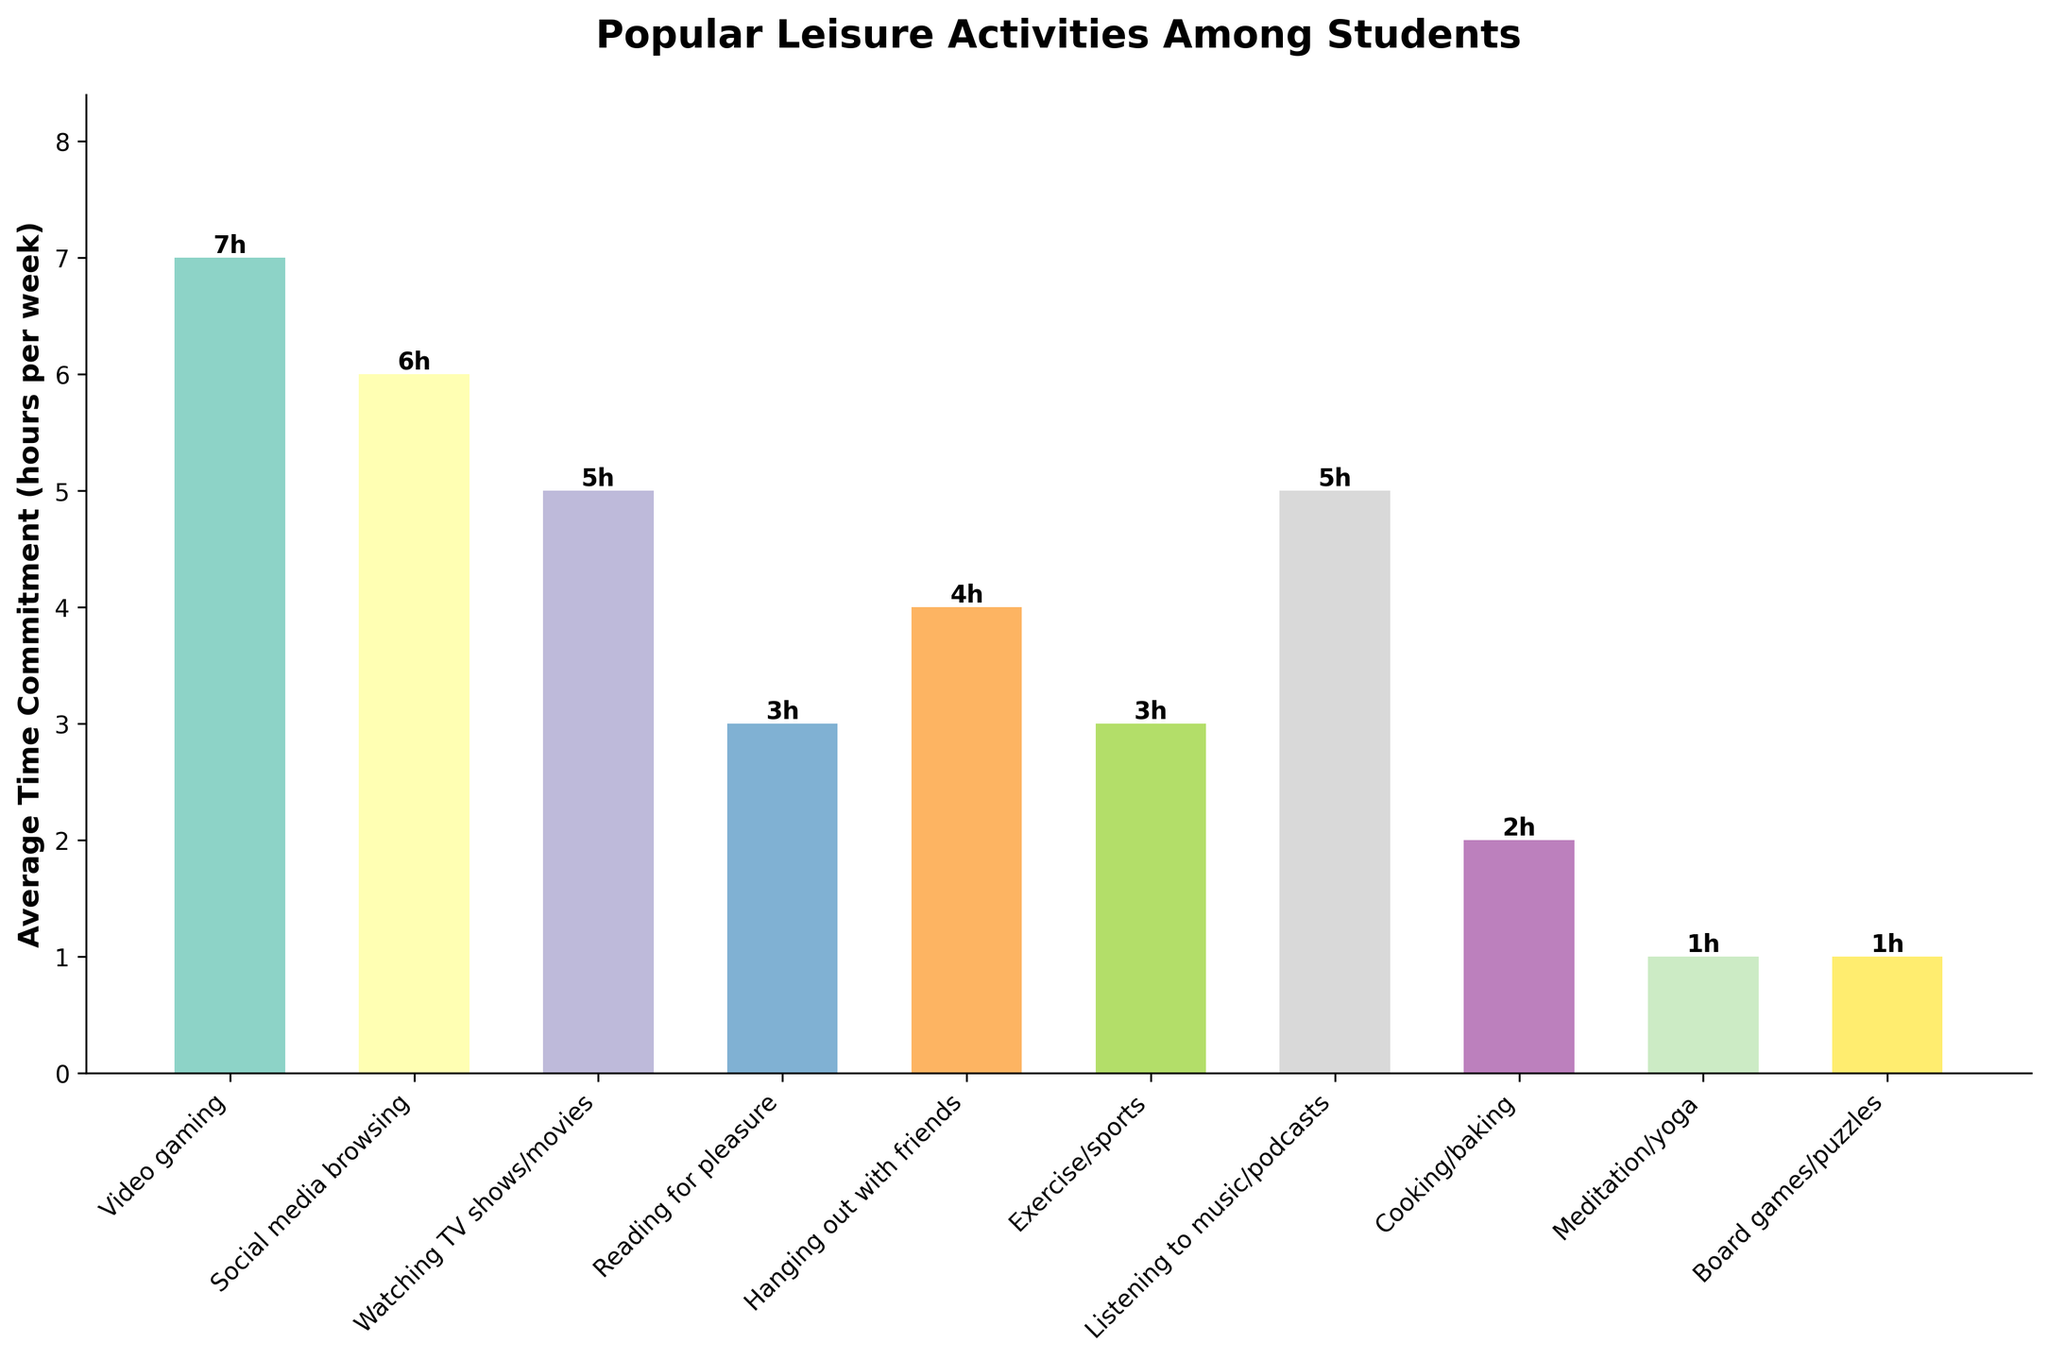Which activity has the highest average time commitment? To find the activity with the highest average time commitment, we look for the tallest bar in the chart. The bar for Video gaming is the tallest at 7 hours per week.
Answer: Video gaming What is the total average time spent on Exercise/sports and Meditation/yoga combined? We add the average time commitments for Exercise/sports (3 hours) and Meditation/yoga (1 hour). The sum is 3 + 1 = 4 hours per week.
Answer: 4 hours How much more time do students spend on Social media browsing compared to Cooking/baking? We look at the heights of the bars for Social media browsing (6 hours) and Cooking/baking (2 hours). The difference is 6 - 2 = 4 hours per week.
Answer: 4 hours Which two activities have the same average time commitment? By observing the heights of the bars, we see that Watching TV shows/movies and Listening to music/podcasts both have the same time commitment of 5 hours per week.
Answer: Watching TV shows/movies and Listening to music/podcasts What is the average time commitment across all activities? We sum the average time commitments of all activities and divide by the number of activities: (7 + 6 + 5 + 3 + 4 + 3 + 5 + 2 + 1 + 1) / 10 = 37 / 10 = 3.7 hours per week.
Answer: 3.7 hours Which activity has the lowest average time commitment? We find the shortest bar in the chart, which corresponds to Meditation/yoga and Board games/puzzles, both at 1 hour per week.
Answer: Meditation/yoga and Board games/puzzles How much more time do students spend on Hanging out with friends than on Reading for pleasure? We compare the average time commitments of Hanging out with friends (4 hours) and Reading for pleasure (3 hours). The difference is 4 - 3 = 1 hour per week.
Answer: 1 hour Rank the activities from highest to lowest average time commitment. By comparing the heights of the bars, we get the ranking: 1) Video gaming (7 hours), 2) Social media browsing (6 hours), 3) Watching TV shows/movies and Listening to music/podcasts (5 hours), 5) Hanging out with friends (4 hours), 6) Reading for pleasure and Exercise/sports (3 hours), 8) Cooking/baking (2 hours), 9) Meditation/yoga and Board games/puzzles (1 hour).
Answer: Video gaming, Social media browsing, Watching TV shows/movies, Listening to music/podcasts, Hanging out with friends, Reading for pleasure, Exercise/sports, Cooking/baking, Meditation/yoga, Board games/puzzles 